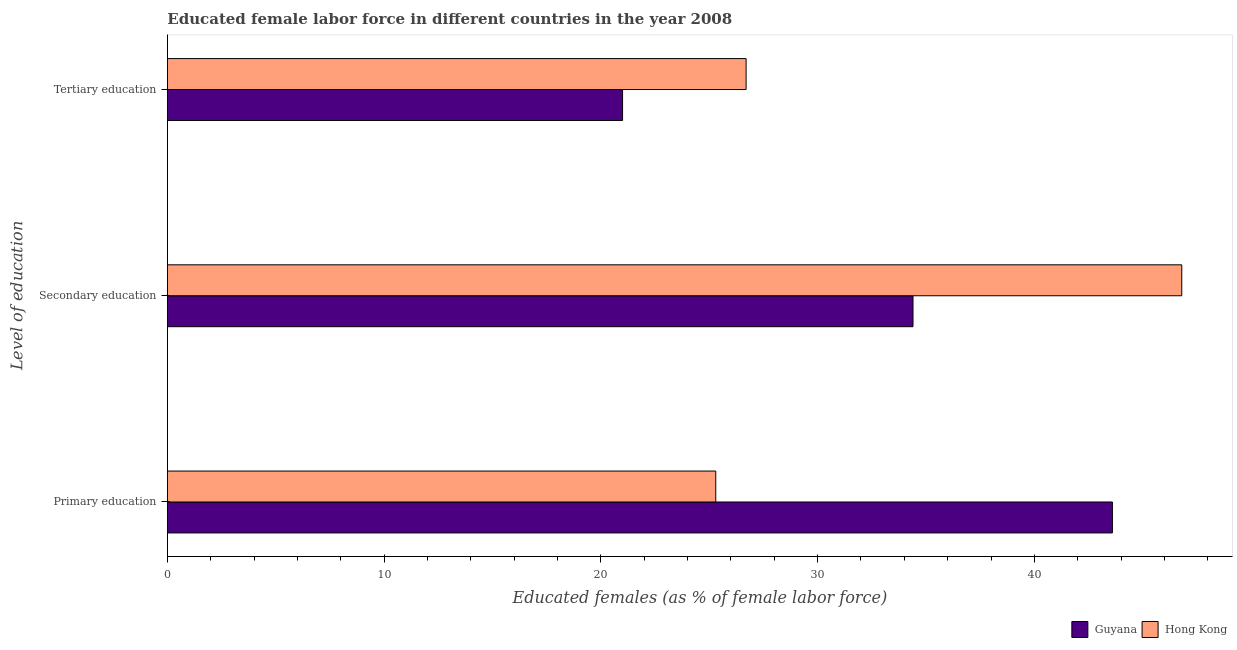Are the number of bars per tick equal to the number of legend labels?
Your answer should be compact. Yes. What is the percentage of female labor force who received primary education in Hong Kong?
Offer a very short reply. 25.3. Across all countries, what is the maximum percentage of female labor force who received tertiary education?
Ensure brevity in your answer.  26.7. Across all countries, what is the minimum percentage of female labor force who received tertiary education?
Make the answer very short. 21. In which country was the percentage of female labor force who received primary education maximum?
Your answer should be very brief. Guyana. In which country was the percentage of female labor force who received primary education minimum?
Give a very brief answer. Hong Kong. What is the total percentage of female labor force who received tertiary education in the graph?
Keep it short and to the point. 47.7. What is the difference between the percentage of female labor force who received primary education in Guyana and that in Hong Kong?
Give a very brief answer. 18.3. What is the difference between the percentage of female labor force who received primary education in Hong Kong and the percentage of female labor force who received tertiary education in Guyana?
Keep it short and to the point. 4.3. What is the average percentage of female labor force who received secondary education per country?
Provide a short and direct response. 40.6. What is the difference between the percentage of female labor force who received secondary education and percentage of female labor force who received tertiary education in Hong Kong?
Your response must be concise. 20.1. What is the ratio of the percentage of female labor force who received secondary education in Hong Kong to that in Guyana?
Ensure brevity in your answer.  1.36. Is the percentage of female labor force who received primary education in Guyana less than that in Hong Kong?
Your answer should be very brief. No. What is the difference between the highest and the second highest percentage of female labor force who received secondary education?
Offer a terse response. 12.4. What is the difference between the highest and the lowest percentage of female labor force who received tertiary education?
Keep it short and to the point. 5.7. Is the sum of the percentage of female labor force who received tertiary education in Guyana and Hong Kong greater than the maximum percentage of female labor force who received secondary education across all countries?
Give a very brief answer. Yes. What does the 2nd bar from the top in Tertiary education represents?
Give a very brief answer. Guyana. What does the 1st bar from the bottom in Secondary education represents?
Give a very brief answer. Guyana. How many bars are there?
Provide a short and direct response. 6. Are all the bars in the graph horizontal?
Keep it short and to the point. Yes. What is the difference between two consecutive major ticks on the X-axis?
Offer a very short reply. 10. Does the graph contain any zero values?
Make the answer very short. No. Does the graph contain grids?
Offer a terse response. No. How are the legend labels stacked?
Provide a short and direct response. Horizontal. What is the title of the graph?
Keep it short and to the point. Educated female labor force in different countries in the year 2008. What is the label or title of the X-axis?
Provide a short and direct response. Educated females (as % of female labor force). What is the label or title of the Y-axis?
Your response must be concise. Level of education. What is the Educated females (as % of female labor force) in Guyana in Primary education?
Give a very brief answer. 43.6. What is the Educated females (as % of female labor force) in Hong Kong in Primary education?
Keep it short and to the point. 25.3. What is the Educated females (as % of female labor force) in Guyana in Secondary education?
Your answer should be compact. 34.4. What is the Educated females (as % of female labor force) of Hong Kong in Secondary education?
Provide a short and direct response. 46.8. What is the Educated females (as % of female labor force) in Guyana in Tertiary education?
Your answer should be compact. 21. What is the Educated females (as % of female labor force) in Hong Kong in Tertiary education?
Your answer should be compact. 26.7. Across all Level of education, what is the maximum Educated females (as % of female labor force) in Guyana?
Your answer should be compact. 43.6. Across all Level of education, what is the maximum Educated females (as % of female labor force) of Hong Kong?
Give a very brief answer. 46.8. Across all Level of education, what is the minimum Educated females (as % of female labor force) in Guyana?
Keep it short and to the point. 21. Across all Level of education, what is the minimum Educated females (as % of female labor force) of Hong Kong?
Keep it short and to the point. 25.3. What is the total Educated females (as % of female labor force) in Guyana in the graph?
Ensure brevity in your answer.  99. What is the total Educated females (as % of female labor force) in Hong Kong in the graph?
Make the answer very short. 98.8. What is the difference between the Educated females (as % of female labor force) in Hong Kong in Primary education and that in Secondary education?
Give a very brief answer. -21.5. What is the difference between the Educated females (as % of female labor force) in Guyana in Primary education and that in Tertiary education?
Give a very brief answer. 22.6. What is the difference between the Educated females (as % of female labor force) in Hong Kong in Secondary education and that in Tertiary education?
Provide a succinct answer. 20.1. What is the difference between the Educated females (as % of female labor force) in Guyana in Primary education and the Educated females (as % of female labor force) in Hong Kong in Secondary education?
Make the answer very short. -3.2. What is the average Educated females (as % of female labor force) of Guyana per Level of education?
Ensure brevity in your answer.  33. What is the average Educated females (as % of female labor force) in Hong Kong per Level of education?
Offer a very short reply. 32.93. What is the difference between the Educated females (as % of female labor force) in Guyana and Educated females (as % of female labor force) in Hong Kong in Primary education?
Make the answer very short. 18.3. What is the difference between the Educated females (as % of female labor force) in Guyana and Educated females (as % of female labor force) in Hong Kong in Secondary education?
Keep it short and to the point. -12.4. What is the difference between the Educated females (as % of female labor force) in Guyana and Educated females (as % of female labor force) in Hong Kong in Tertiary education?
Your answer should be very brief. -5.7. What is the ratio of the Educated females (as % of female labor force) in Guyana in Primary education to that in Secondary education?
Offer a very short reply. 1.27. What is the ratio of the Educated females (as % of female labor force) in Hong Kong in Primary education to that in Secondary education?
Make the answer very short. 0.54. What is the ratio of the Educated females (as % of female labor force) of Guyana in Primary education to that in Tertiary education?
Ensure brevity in your answer.  2.08. What is the ratio of the Educated females (as % of female labor force) in Hong Kong in Primary education to that in Tertiary education?
Give a very brief answer. 0.95. What is the ratio of the Educated females (as % of female labor force) of Guyana in Secondary education to that in Tertiary education?
Offer a terse response. 1.64. What is the ratio of the Educated females (as % of female labor force) of Hong Kong in Secondary education to that in Tertiary education?
Your answer should be very brief. 1.75. What is the difference between the highest and the second highest Educated females (as % of female labor force) of Hong Kong?
Your answer should be very brief. 20.1. What is the difference between the highest and the lowest Educated females (as % of female labor force) of Guyana?
Provide a short and direct response. 22.6. 